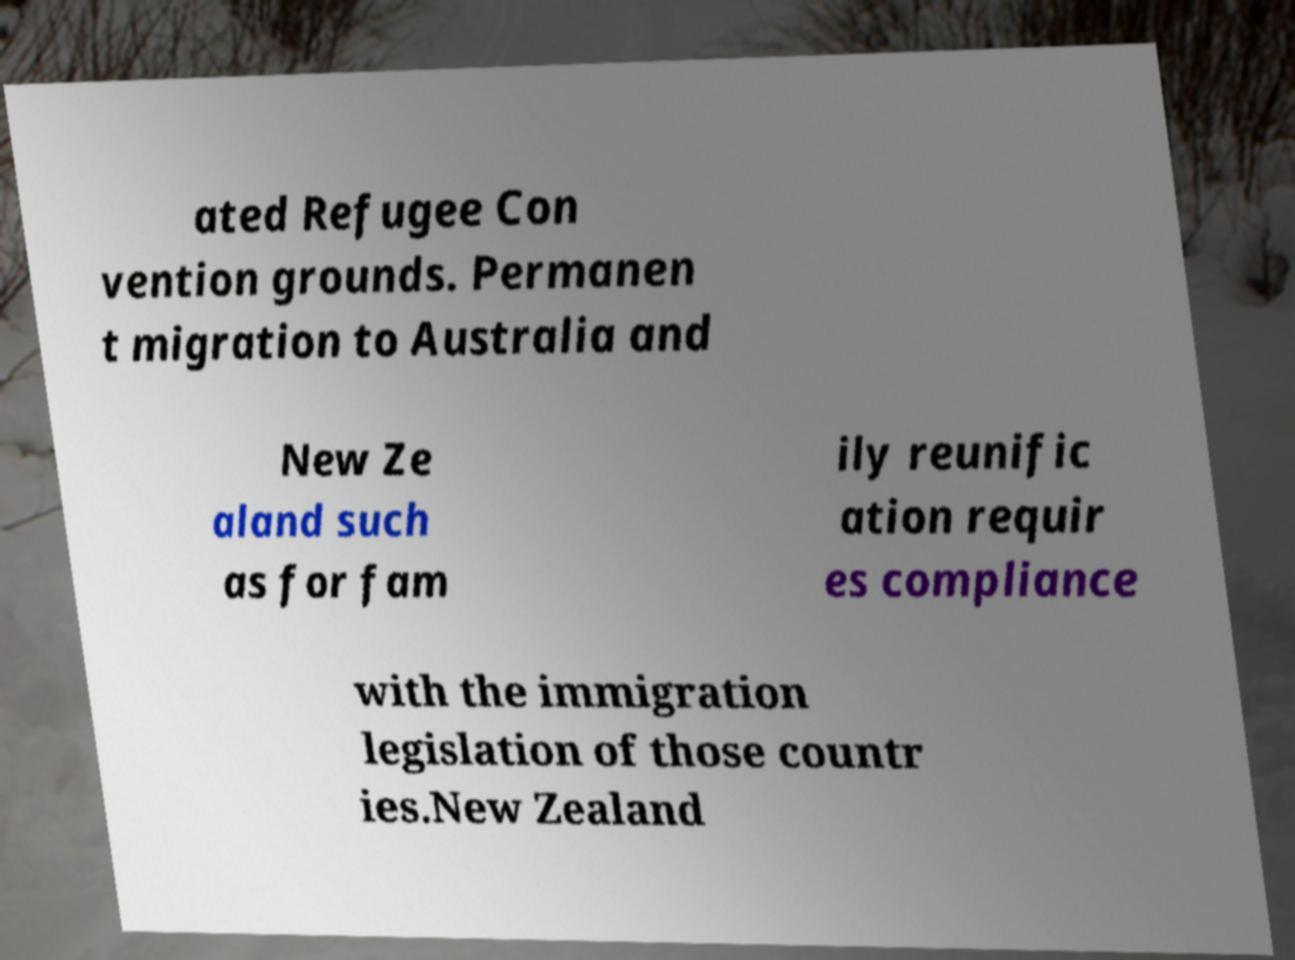What messages or text are displayed in this image? I need them in a readable, typed format. ated Refugee Con vention grounds. Permanen t migration to Australia and New Ze aland such as for fam ily reunific ation requir es compliance with the immigration legislation of those countr ies.New Zealand 